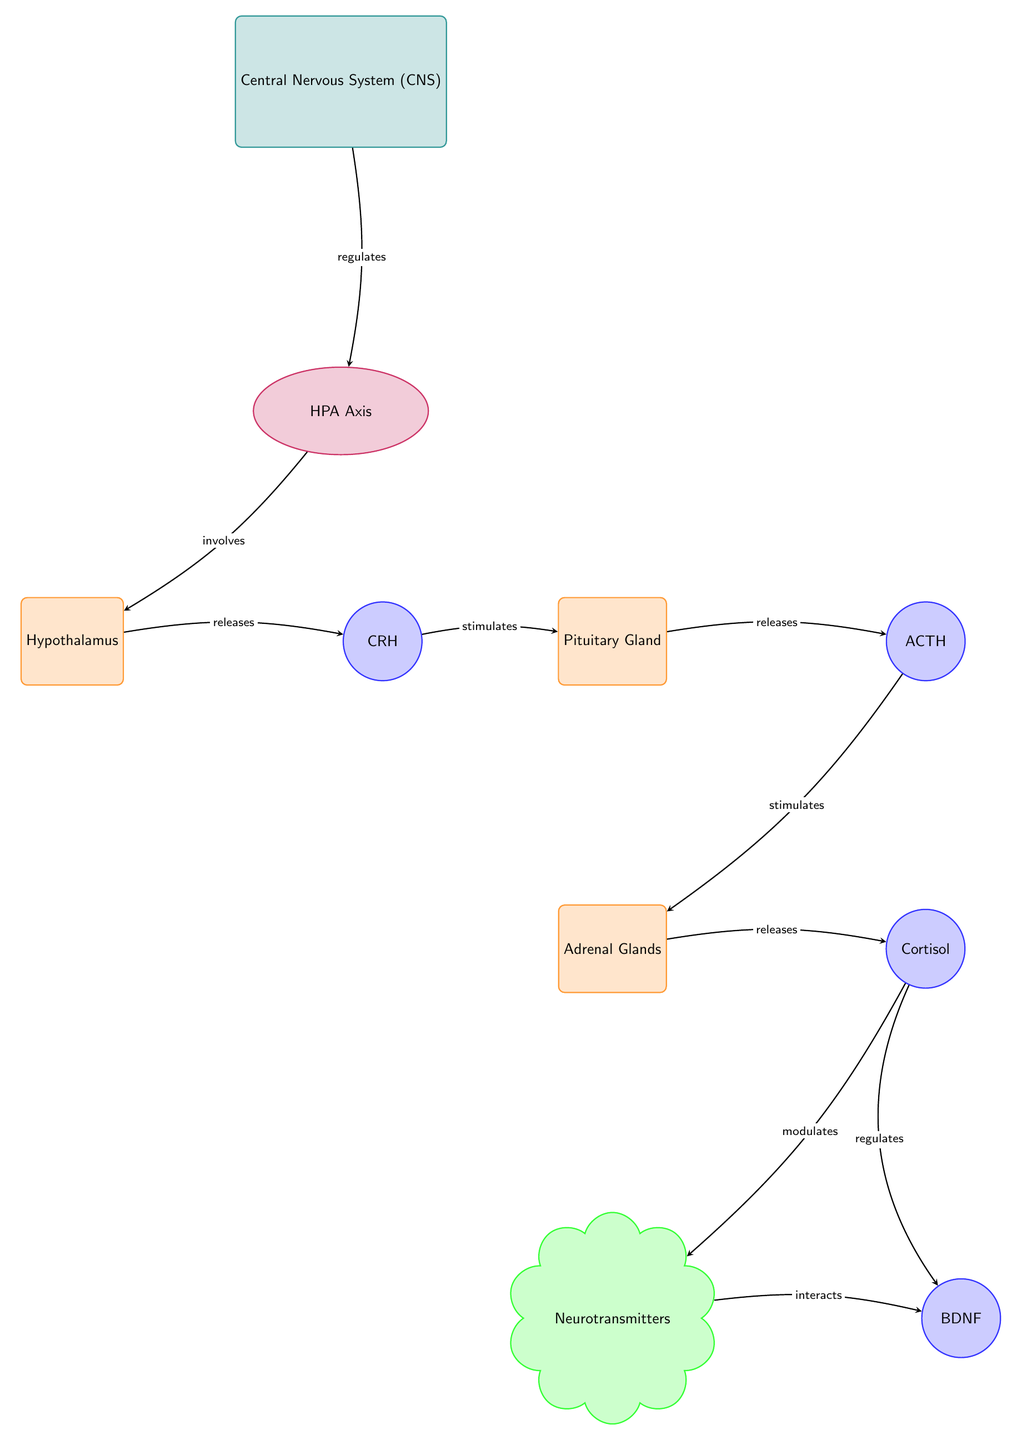What regulates the HPA Axis? The diagram indicates that the Central Nervous System regulates the HPA Axis, as shown by the directed edge between the CNS and HPA with the label "regulates."
Answer: Central Nervous System Which organ releases ACTH? According to the diagram, the directed edge from the Pituitary Gland to ACTH labeled "releases" indicates that the Pituitary releases ACTH.
Answer: Pituitary Gland What biomolecule interacts with neurotransmitters? The diagram shows an interaction between Neurotransmitters and BDNF, denoted by the edge labeled "interacts" connecting these two nodes.
Answer: BDNF How does cortisol affect BDNF? The diagram provides two edges, one labeled "modulates" from Cortisol to Neurotransmitters and another labeled "regulates" from Cortisol to BDNF, indicating that Cortisol influences BDNF directly and through Neurotransmitters.
Answer: regulates What is the sequence of hormone release starting from the hypothalamus? The sequence is as follows: Hypothalamus releases CRH, which stimulates the Pituitary Gland to release ACTH, and ACTH then stimulates the Adrenal Glands to release Cortisol. This flow through multiple edges provides the complete sequence of hormone release.
Answer: CRH, ACTH, Cortisol How many total biomolecules are present in the diagram? By counting the nodes categorized as biomolecules in the diagram, we can find CRH, ACTH, Cortisol, and BDNF, resulting in a total of four biomolecule nodes.
Answer: 4 What is the relationship between cortisol and neurotransmitters? The diagram shows that cortisol "modulates" neurotransmitters, which indicates a direct influencing relationship.
Answer: modulates What structures are involved in the HPA Axis? The diagram features the Hypothalamus, Pituitary Gland, and Adrenal Glands as the key structures involved in the HPA Axis, as indicated by their placement under the HPA Axis pathway.
Answer: Hypothalamus, Pituitary Gland, Adrenal Glands 